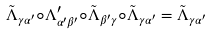Convert formula to latex. <formula><loc_0><loc_0><loc_500><loc_500>\tilde { \Lambda } _ { \gamma \alpha ^ { \prime } } \circ \Lambda _ { \alpha ^ { \prime } \beta ^ { \prime } } ^ { \prime } \circ \tilde { \Lambda } _ { \beta ^ { \prime } \gamma } \circ \tilde { \Lambda } _ { \gamma \alpha ^ { \prime } } = \tilde { \Lambda } _ { \gamma \alpha ^ { \prime } }</formula> 